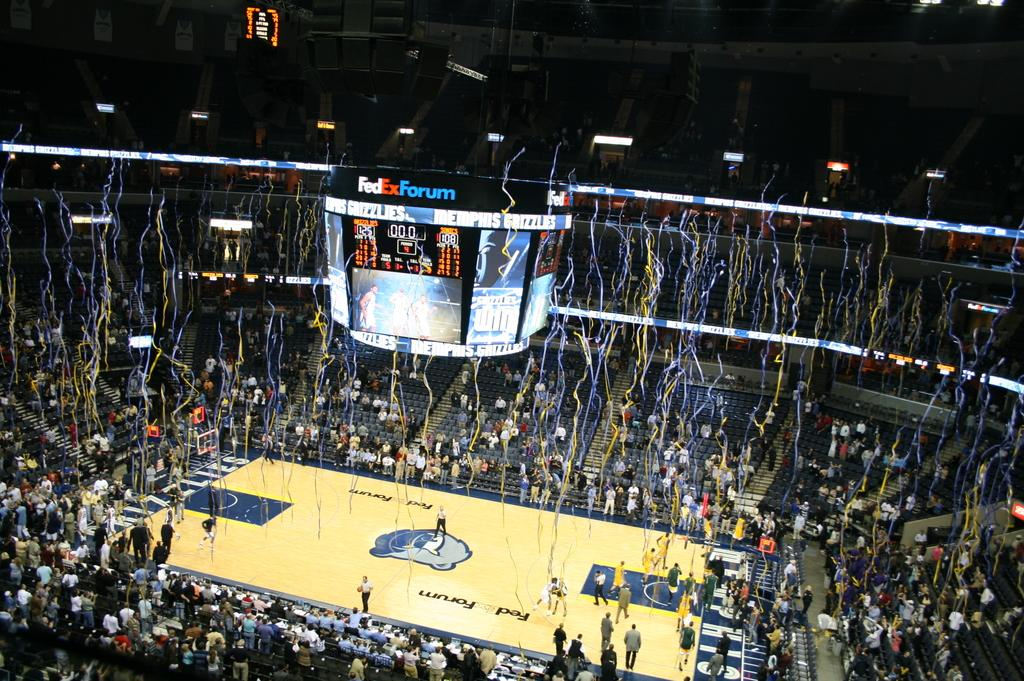<image>
Present a compact description of the photo's key features. Basketball stadium that has confetti falling in the FexEx Forum. 